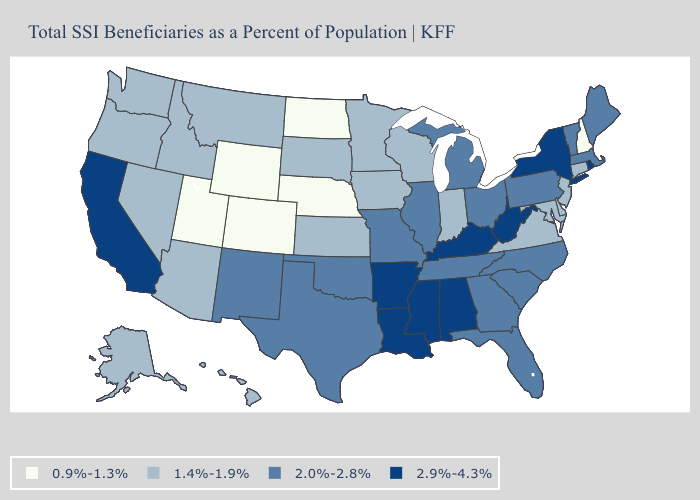Does Wyoming have a lower value than Nebraska?
Give a very brief answer. No. What is the highest value in the MidWest ?
Be succinct. 2.0%-2.8%. What is the lowest value in the USA?
Keep it brief. 0.9%-1.3%. Among the states that border Maryland , which have the lowest value?
Short answer required. Delaware, Virginia. What is the value of Nevada?
Give a very brief answer. 1.4%-1.9%. Name the states that have a value in the range 1.4%-1.9%?
Keep it brief. Alaska, Arizona, Connecticut, Delaware, Hawaii, Idaho, Indiana, Iowa, Kansas, Maryland, Minnesota, Montana, Nevada, New Jersey, Oregon, South Dakota, Virginia, Washington, Wisconsin. Is the legend a continuous bar?
Keep it brief. No. Among the states that border Vermont , does Massachusetts have the highest value?
Keep it brief. No. Name the states that have a value in the range 1.4%-1.9%?
Quick response, please. Alaska, Arizona, Connecticut, Delaware, Hawaii, Idaho, Indiana, Iowa, Kansas, Maryland, Minnesota, Montana, Nevada, New Jersey, Oregon, South Dakota, Virginia, Washington, Wisconsin. Name the states that have a value in the range 2.0%-2.8%?
Keep it brief. Florida, Georgia, Illinois, Maine, Massachusetts, Michigan, Missouri, New Mexico, North Carolina, Ohio, Oklahoma, Pennsylvania, South Carolina, Tennessee, Texas, Vermont. Does Delaware have the lowest value in the South?
Concise answer only. Yes. Does Arizona have a lower value than Mississippi?
Give a very brief answer. Yes. Which states hav the highest value in the West?
Give a very brief answer. California. What is the value of Delaware?
Concise answer only. 1.4%-1.9%. What is the value of West Virginia?
Write a very short answer. 2.9%-4.3%. 